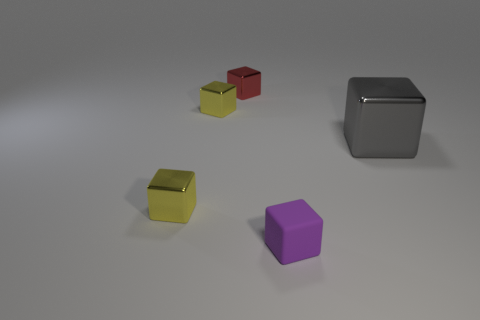There is a metal block that is on the right side of the purple matte object; what number of small things are in front of it?
Make the answer very short. 2. How many blocks are tiny rubber objects or big gray objects?
Make the answer very short. 2. What is the color of the tiny cube that is in front of the gray thing and left of the rubber object?
Provide a succinct answer. Yellow. Are there any other things that are the same color as the rubber block?
Offer a terse response. No. The small block on the right side of the small red metallic block left of the large object is what color?
Keep it short and to the point. Purple. Do the matte block and the red metal object have the same size?
Your response must be concise. Yes. Are the cube to the right of the tiny purple matte object and the tiny purple cube that is left of the large gray thing made of the same material?
Your response must be concise. No. What is the shape of the metal thing on the right side of the thing that is behind the yellow block behind the large shiny thing?
Offer a very short reply. Cube. Is the number of red metal things greater than the number of small red spheres?
Keep it short and to the point. Yes. Are there any small metal objects?
Provide a short and direct response. Yes. 